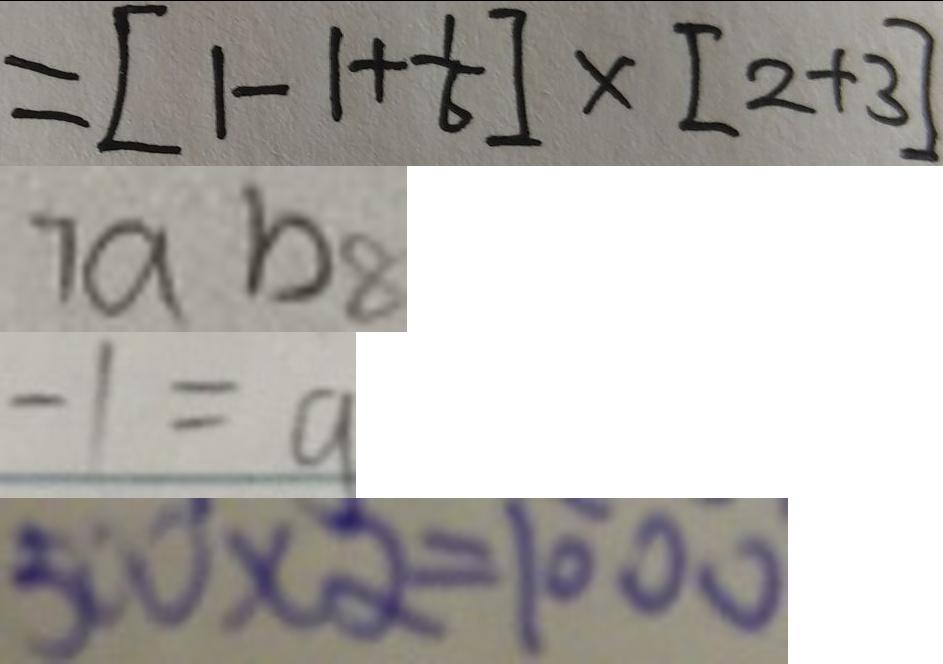Convert formula to latex. <formula><loc_0><loc_0><loc_500><loc_500>= [ 1 - 1 + \frac { 1 } { 6 } ] \times [ 2 + 3 ] 
 7 a b 8 
 - 1 = a 
 5 0 0 \times 2 = 1 0 0 0</formula> 